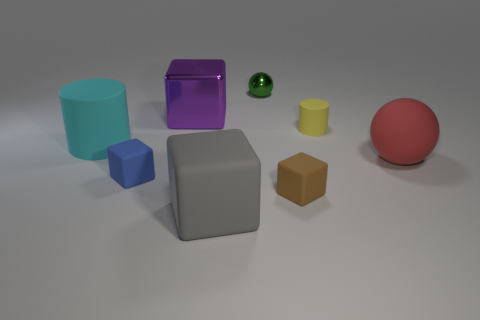What color is the other big metallic thing that is the same shape as the large gray object?
Your response must be concise. Purple. What is the shape of the rubber thing right of the cylinder that is right of the small rubber cube on the right side of the tiny blue rubber object?
Your answer should be very brief. Sphere. There is a matte cylinder that is on the right side of the big shiny block; is its size the same as the brown block to the right of the tiny metal object?
Your answer should be very brief. Yes. How many gray things are made of the same material as the large cyan cylinder?
Make the answer very short. 1. How many large rubber objects are to the right of the matte cylinder that is on the left side of the blue matte object behind the big gray rubber thing?
Provide a succinct answer. 2. Is the blue object the same shape as the cyan thing?
Ensure brevity in your answer.  No. Are there any brown matte objects that have the same shape as the blue object?
Your answer should be very brief. Yes. The cyan matte thing that is the same size as the metallic cube is what shape?
Your answer should be very brief. Cylinder. What material is the sphere that is to the left of the small block that is on the right side of the large cube behind the big rubber cube made of?
Give a very brief answer. Metal. Do the blue rubber object and the cyan cylinder have the same size?
Offer a very short reply. No. 